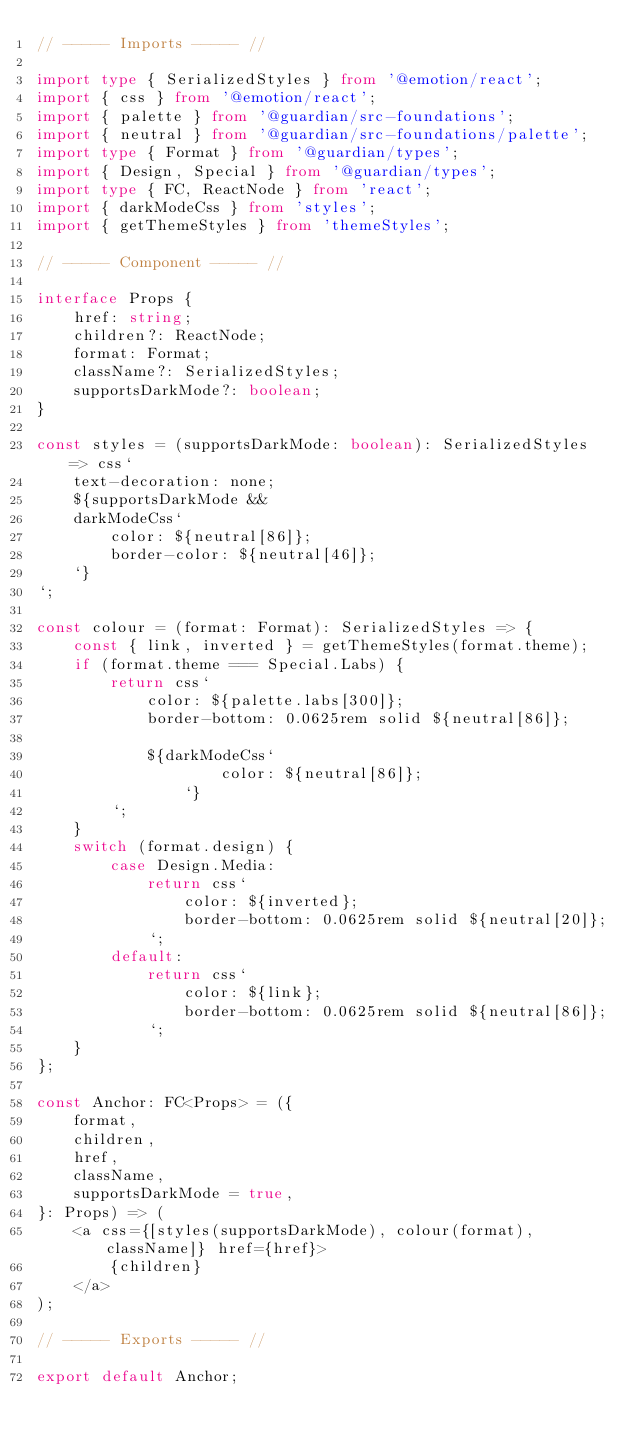Convert code to text. <code><loc_0><loc_0><loc_500><loc_500><_TypeScript_>// ----- Imports ----- //

import type { SerializedStyles } from '@emotion/react';
import { css } from '@emotion/react';
import { palette } from '@guardian/src-foundations';
import { neutral } from '@guardian/src-foundations/palette';
import type { Format } from '@guardian/types';
import { Design, Special } from '@guardian/types';
import type { FC, ReactNode } from 'react';
import { darkModeCss } from 'styles';
import { getThemeStyles } from 'themeStyles';

// ----- Component ----- //

interface Props {
	href: string;
	children?: ReactNode;
	format: Format;
	className?: SerializedStyles;
	supportsDarkMode?: boolean;
}

const styles = (supportsDarkMode: boolean): SerializedStyles => css`
	text-decoration: none;
	${supportsDarkMode &&
	darkModeCss`
        color: ${neutral[86]};
        border-color: ${neutral[46]};
    `}
`;

const colour = (format: Format): SerializedStyles => {
	const { link, inverted } = getThemeStyles(format.theme);
	if (format.theme === Special.Labs) {
		return css`
			color: ${palette.labs[300]};
			border-bottom: 0.0625rem solid ${neutral[86]};

			${darkModeCss`
                    color: ${neutral[86]};
                `}
		`;
	}
	switch (format.design) {
		case Design.Media:
			return css`
				color: ${inverted};
				border-bottom: 0.0625rem solid ${neutral[20]};
			`;
		default:
			return css`
				color: ${link};
				border-bottom: 0.0625rem solid ${neutral[86]};
			`;
	}
};

const Anchor: FC<Props> = ({
	format,
	children,
	href,
	className,
	supportsDarkMode = true,
}: Props) => (
	<a css={[styles(supportsDarkMode), colour(format), className]} href={href}>
		{children}
	</a>
);

// ----- Exports ----- //

export default Anchor;
</code> 